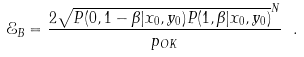Convert formula to latex. <formula><loc_0><loc_0><loc_500><loc_500>\mathcal { E } _ { B } = \frac { 2 \sqrt { P ( 0 , 1 - \beta | x _ { 0 } , y _ { 0 } ) P ( 1 , \beta | x _ { 0 } , y _ { 0 } ) } ^ { N } } { p _ { O K } } \ .</formula> 